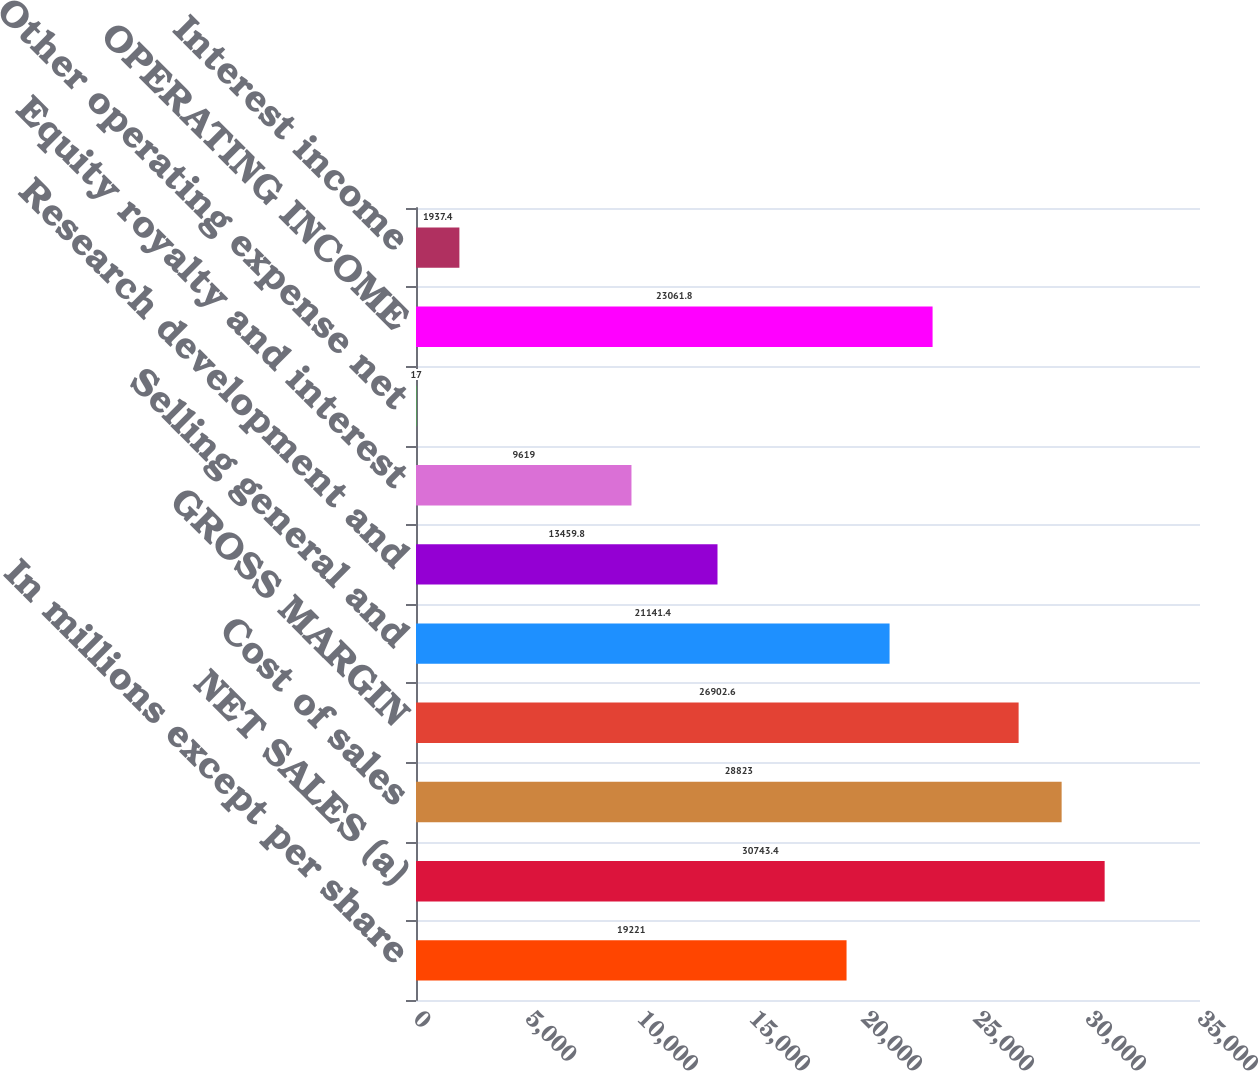Convert chart to OTSL. <chart><loc_0><loc_0><loc_500><loc_500><bar_chart><fcel>In millions except per share<fcel>NET SALES (a)<fcel>Cost of sales<fcel>GROSS MARGIN<fcel>Selling general and<fcel>Research development and<fcel>Equity royalty and interest<fcel>Other operating expense net<fcel>OPERATING INCOME<fcel>Interest income<nl><fcel>19221<fcel>30743.4<fcel>28823<fcel>26902.6<fcel>21141.4<fcel>13459.8<fcel>9619<fcel>17<fcel>23061.8<fcel>1937.4<nl></chart> 